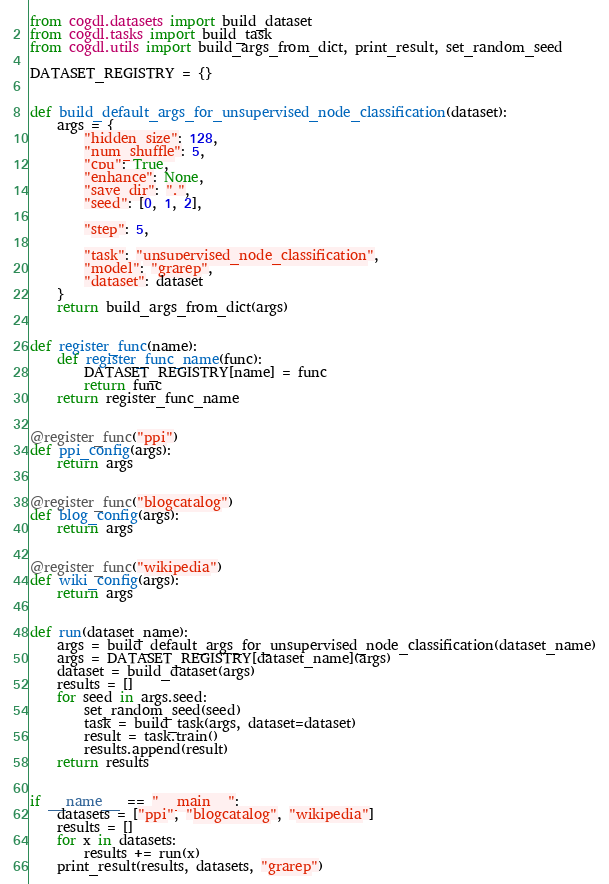Convert code to text. <code><loc_0><loc_0><loc_500><loc_500><_Python_>from cogdl.datasets import build_dataset
from cogdl.tasks import build_task
from cogdl.utils import build_args_from_dict, print_result, set_random_seed

DATASET_REGISTRY = {}


def build_default_args_for_unsupervised_node_classification(dataset):
    args = {
        "hidden_size": 128,
        "num_shuffle": 5,
        "cpu": True,
        "enhance": None,
        "save_dir": ".",
        "seed": [0, 1, 2],

        "step": 5,

        "task": "unsupervised_node_classification",
        "model": "grarep",
        "dataset": dataset
    }
    return build_args_from_dict(args)


def register_func(name):
    def register_func_name(func):
        DATASET_REGISTRY[name] = func
        return func
    return register_func_name


@register_func("ppi")
def ppi_config(args):
    return args


@register_func("blogcatalog")
def blog_config(args):
    return args


@register_func("wikipedia")
def wiki_config(args):
    return args


def run(dataset_name):
    args = build_default_args_for_unsupervised_node_classification(dataset_name)
    args = DATASET_REGISTRY[dataset_name](args)
    dataset = build_dataset(args)
    results = []
    for seed in args.seed:
        set_random_seed(seed)
        task = build_task(args, dataset=dataset)
        result = task.train()
        results.append(result)
    return results


if __name__ == "__main__":
    datasets = ["ppi", "blogcatalog", "wikipedia"]
    results = []
    for x in datasets:
        results += run(x)
    print_result(results, datasets, "grarep")
</code> 